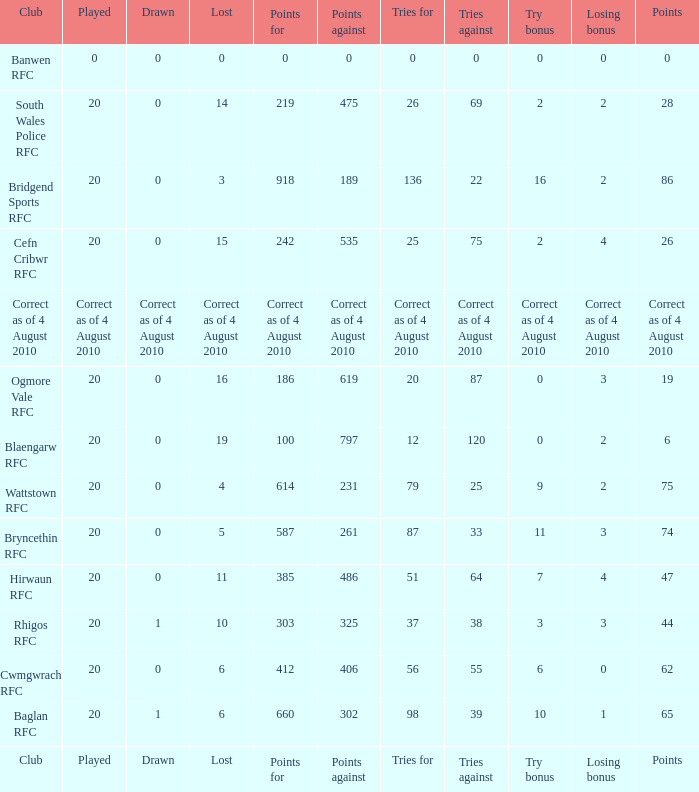What is drawn when the club is hirwaun rfc? 0.0. 